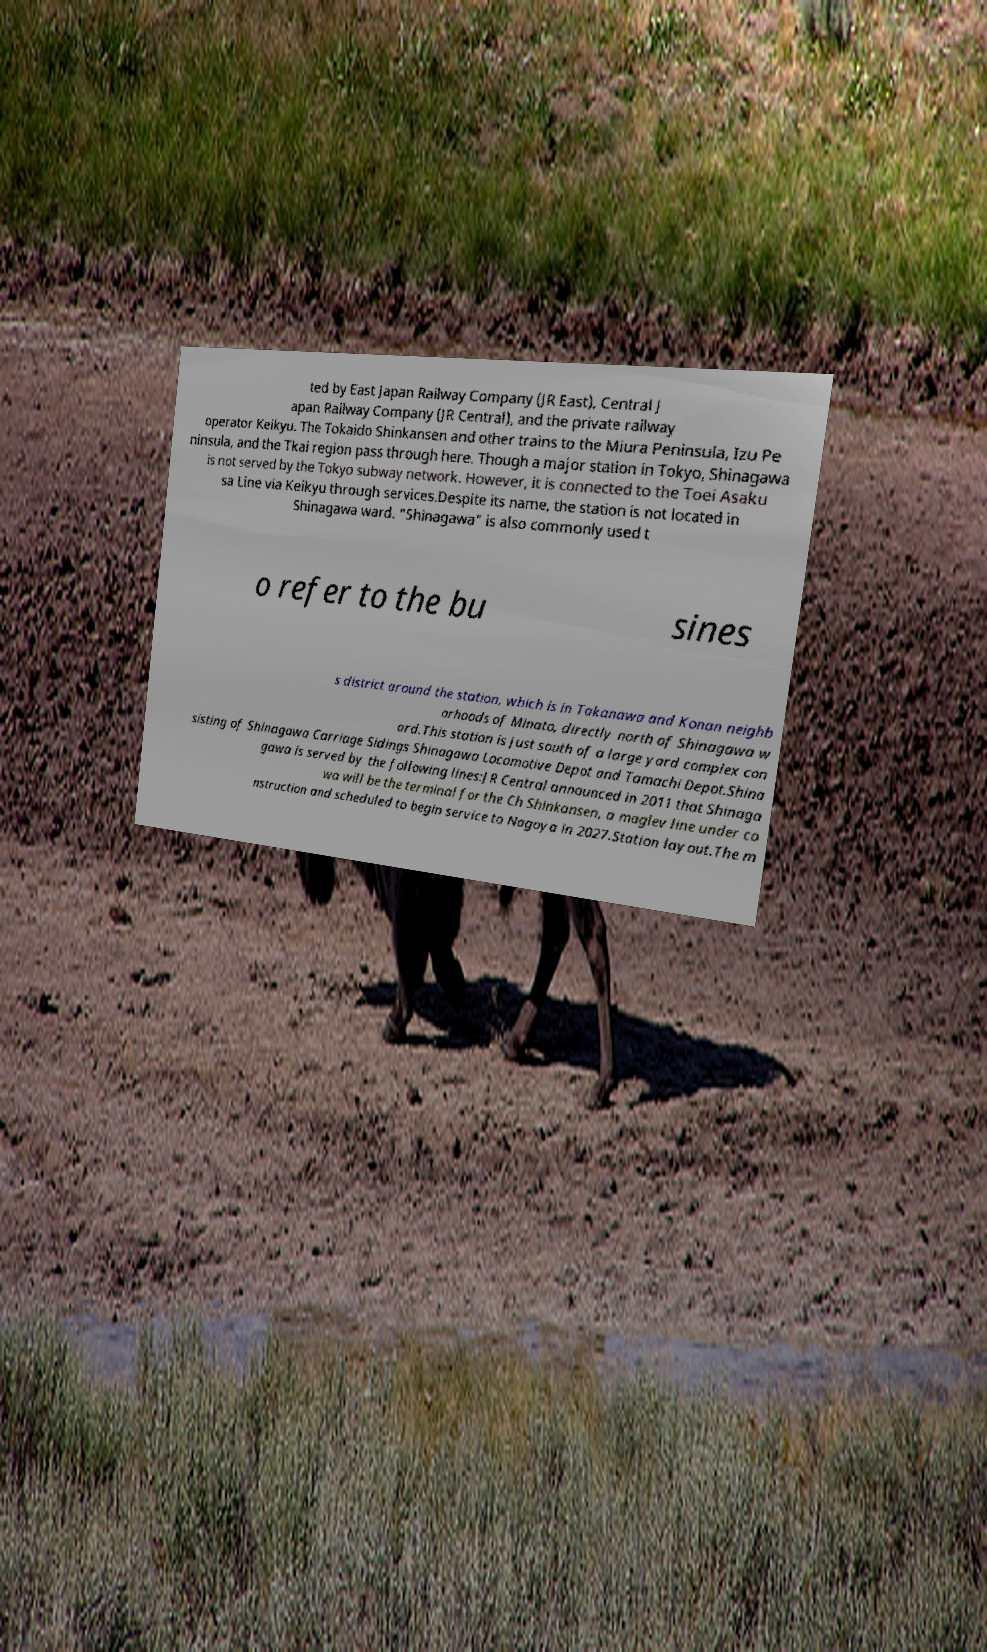Please read and relay the text visible in this image. What does it say? ted by East Japan Railway Company (JR East), Central J apan Railway Company (JR Central), and the private railway operator Keikyu. The Tokaido Shinkansen and other trains to the Miura Peninsula, Izu Pe ninsula, and the Tkai region pass through here. Though a major station in Tokyo, Shinagawa is not served by the Tokyo subway network. However, it is connected to the Toei Asaku sa Line via Keikyu through services.Despite its name, the station is not located in Shinagawa ward. "Shinagawa" is also commonly used t o refer to the bu sines s district around the station, which is in Takanawa and Konan neighb orhoods of Minato, directly north of Shinagawa w ard.This station is just south of a large yard complex con sisting of Shinagawa Carriage Sidings Shinagawa Locomotive Depot and Tamachi Depot.Shina gawa is served by the following lines:JR Central announced in 2011 that Shinaga wa will be the terminal for the Ch Shinkansen, a maglev line under co nstruction and scheduled to begin service to Nagoya in 2027.Station layout.The m 